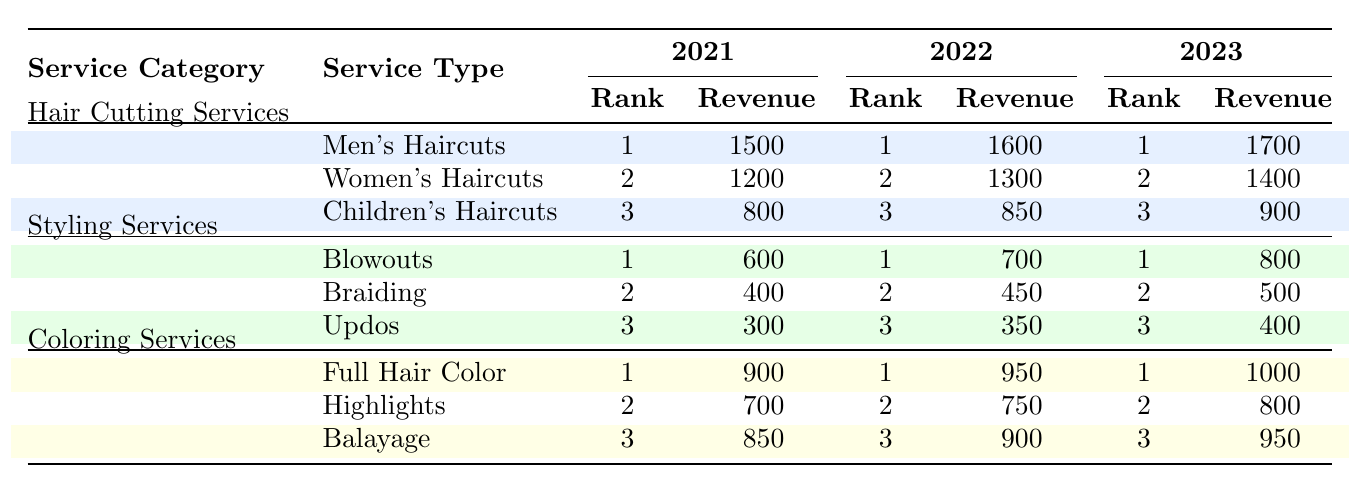What was the monthly average revenue for Men's Haircuts in 2022? In the table, under the "Hair Cutting Services" category for the year 2022, the monthly average revenue for Men's Haircuts is listed as 1600.
Answer: 1600 Did the popularity rank of Women's Haircuts change from 2021 to 2023? Looking at the table, Women's Haircuts ranked 2nd in both 2021 and 2023, indicating that its popularity rank remained the same over the years.
Answer: No What is the total monthly average revenue for all Hair Cutting Services in 2023? To find the total revenue for Hair Cutting Services in 2023, we add the monthly average revenues: 1700 (Men's) + 1400 (Women's) + 900 (Children's) = 4000.
Answer: 4000 Was the revenue for Blowouts higher than that for Updos in 2022? Checking the table, in 2022, Blowouts had a revenue of 700, while Updos had a revenue of 350. Since 700 is greater than 350, the statement is true.
Answer: Yes Which service had the highest revenue increase from 2021 to 2023? We can compare the revenue for each service across the years. For Mens' Haircuts, the revenue increased from 1500 in 2021 to 1700 in 2023 (200 increase). For Women's Haircuts, the increase was from 1200 to 1400 (200 increase). For Children's Haircuts, it increased from 800 to 900 (100 increase). The same comparison for styling and coloring shows the highest increase is for Full Hair Color with an increase from 900 to 1000 (100 increase). Thus, both Men's and Women's Haircuts had the highest increase.
Answer: Men's and Women's Haircuts What is the average monthly revenue for Highlights over the three years? The revenues for Highlights are 700 (2021), 750 (2022), and 800 (2023). To calculate the average, we sum them up: 700 + 750 + 800 = 2250 and then divide by 3. The average is 2250 / 3 = 750.
Answer: 750 Is the popularity rank of Full Hair Color always 1? Looking at the table, Full Hair Color consistently has a popularity rank of 1 across all three years (2021, 2022, and 2023), confirming that it maintained this rank.
Answer: Yes Which service category had the lowest average revenue in 2021? We need to calculate the average revenue for each service category in 2021. For Hair Cutting Services: (1500 + 1200 + 800) / 3 = 1100. For Styling Services: (600 + 400 + 300) / 3 = 433.33. For Coloring Services: (900 + 700 + 850) / 3 = 816.67. Comparing these averages, Styling Services had the lowest average revenue.
Answer: Styling Services 